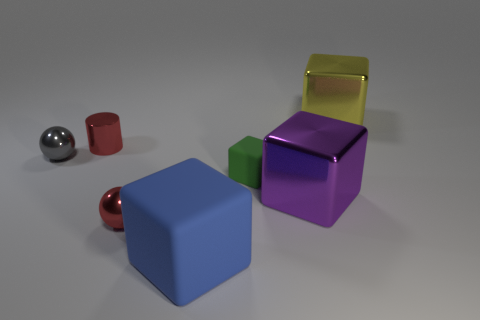What is the size of the metallic ball that is the same color as the tiny cylinder?
Your answer should be compact. Small. Is the material of the purple object the same as the small cylinder?
Offer a very short reply. Yes. The metallic object that is behind the red thing behind the tiny red metal thing in front of the small red shiny cylinder is what color?
Your answer should be compact. Yellow. What shape is the blue matte object?
Ensure brevity in your answer.  Cube. Does the cylinder have the same color as the tiny metal sphere left of the tiny red cylinder?
Make the answer very short. No. Are there an equal number of big purple objects in front of the purple block and red objects?
Give a very brief answer. No. What number of yellow shiny cubes have the same size as the blue block?
Ensure brevity in your answer.  1. What is the shape of the tiny object that is the same color as the small metal cylinder?
Ensure brevity in your answer.  Sphere. Are any large cyan spheres visible?
Keep it short and to the point. No. Does the tiny red metallic thing that is right of the shiny cylinder have the same shape as the red metallic object that is behind the gray sphere?
Ensure brevity in your answer.  No. 